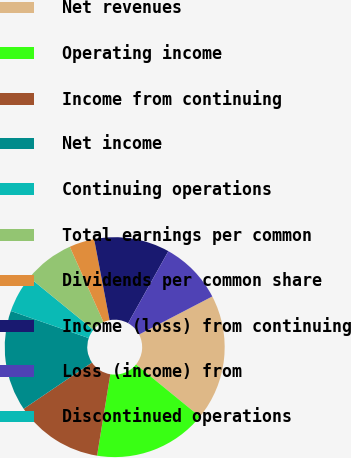Convert chart to OTSL. <chart><loc_0><loc_0><loc_500><loc_500><pie_chart><fcel>Net revenues<fcel>Operating income<fcel>Income from continuing<fcel>Net income<fcel>Continuing operations<fcel>Total earnings per common<fcel>Dividends per common share<fcel>Income (loss) from continuing<fcel>Loss (income) from<fcel>Discontinued operations<nl><fcel>18.52%<fcel>16.67%<fcel>12.96%<fcel>14.81%<fcel>5.56%<fcel>7.41%<fcel>3.7%<fcel>11.11%<fcel>9.26%<fcel>0.0%<nl></chart> 